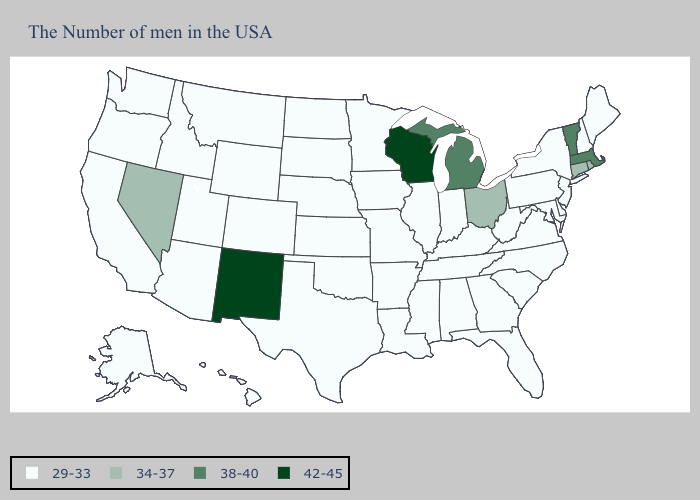Is the legend a continuous bar?
Concise answer only. No. Among the states that border Iowa , does Minnesota have the highest value?
Write a very short answer. No. Name the states that have a value in the range 29-33?
Quick response, please. Maine, New Hampshire, New York, New Jersey, Delaware, Maryland, Pennsylvania, Virginia, North Carolina, South Carolina, West Virginia, Florida, Georgia, Kentucky, Indiana, Alabama, Tennessee, Illinois, Mississippi, Louisiana, Missouri, Arkansas, Minnesota, Iowa, Kansas, Nebraska, Oklahoma, Texas, South Dakota, North Dakota, Wyoming, Colorado, Utah, Montana, Arizona, Idaho, California, Washington, Oregon, Alaska, Hawaii. Does the map have missing data?
Be succinct. No. Which states hav the highest value in the South?
Short answer required. Delaware, Maryland, Virginia, North Carolina, South Carolina, West Virginia, Florida, Georgia, Kentucky, Alabama, Tennessee, Mississippi, Louisiana, Arkansas, Oklahoma, Texas. What is the highest value in the USA?
Be succinct. 42-45. Among the states that border Indiana , which have the lowest value?
Write a very short answer. Kentucky, Illinois. What is the lowest value in the South?
Concise answer only. 29-33. Name the states that have a value in the range 34-37?
Answer briefly. Rhode Island, Connecticut, Ohio, Nevada. Among the states that border Oregon , which have the lowest value?
Quick response, please. Idaho, California, Washington. Name the states that have a value in the range 29-33?
Answer briefly. Maine, New Hampshire, New York, New Jersey, Delaware, Maryland, Pennsylvania, Virginia, North Carolina, South Carolina, West Virginia, Florida, Georgia, Kentucky, Indiana, Alabama, Tennessee, Illinois, Mississippi, Louisiana, Missouri, Arkansas, Minnesota, Iowa, Kansas, Nebraska, Oklahoma, Texas, South Dakota, North Dakota, Wyoming, Colorado, Utah, Montana, Arizona, Idaho, California, Washington, Oregon, Alaska, Hawaii. What is the value of Arkansas?
Concise answer only. 29-33. Which states have the lowest value in the West?
Give a very brief answer. Wyoming, Colorado, Utah, Montana, Arizona, Idaho, California, Washington, Oregon, Alaska, Hawaii. What is the value of California?
Be succinct. 29-33. Name the states that have a value in the range 29-33?
Write a very short answer. Maine, New Hampshire, New York, New Jersey, Delaware, Maryland, Pennsylvania, Virginia, North Carolina, South Carolina, West Virginia, Florida, Georgia, Kentucky, Indiana, Alabama, Tennessee, Illinois, Mississippi, Louisiana, Missouri, Arkansas, Minnesota, Iowa, Kansas, Nebraska, Oklahoma, Texas, South Dakota, North Dakota, Wyoming, Colorado, Utah, Montana, Arizona, Idaho, California, Washington, Oregon, Alaska, Hawaii. 